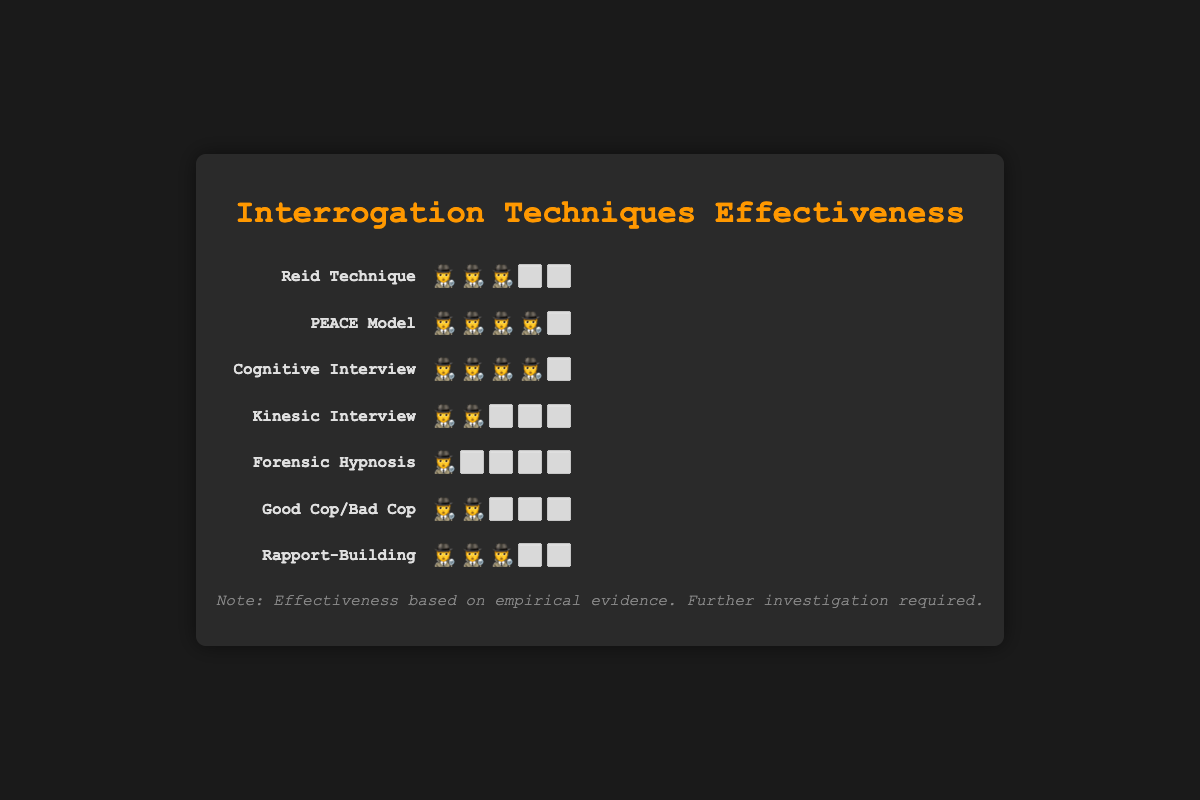Which interrogation technique has the lowest success rate based on the emoji scale? The figure shows that "Forensic Hypnosis" has the fewest emojis (🕵️⬜⬜⬜⬜), indicating it has the lowest success rate.
Answer: Forensic Hypnosis How many techniques have a success rate represented by four emojis? "PEACE Model" and "Cognitive Interview" both have four emojis (🕵️🕵️🕵️🕵️⬜). To determine the number, count these techniques.
Answer: 2 Which techniques have an equal success rate of three emojis? By observing the emoji scales, "Reid Technique" and "Rapport-Building" each have three emojis (🕵️🕵️🕵️⬜⬜).
Answer: Reid Technique, Rapport-Building What is the difference in success rate between the "PEACE Model" and "Good Cop/Bad Cop"? "PEACE Model" has four emojis (🕵️🕵️🕵️🕵️⬜) and "Good Cop/Bad Cop" has two emojis (🕵️🕵️⬜⬜⬜). The difference is 4 - 2 = 2.
Answer: 2 Which techniques share the same success rate as the "Reid Technique"? The "Reid Technique" has three emojis (🕵️🕵️🕵️⬜⬜). "Rapport-Building" also has three emojis.
Answer: Rapport-Building Rank the techniques from highest to lowest success rate based on the emoji scale. The techniques can be ranked by counting the emojis from most to least. "PEACE Model" and "Cognitive Interview" have the highest (four emojis), followed by "Reid Technique" and "Rapport-Building" (three emojis), "Kinesic Interview" and "Good Cop/Bad Cop" (two emojis), and "Forensic Hypnosis" has the lowest success rate (one emoji).
Answer: PEACE Model, Cognitive Interview, Reid Technique, Rapport-Building, Kinesic Interview, Good Cop/Bad Cop, Forensic Hypnosis How many techniques have a success rate less than three emojis? Observing the emoji scales, "Kinesic Interview" (two emojis), "Good Cop/Bad Cop" (two emojis), and "Forensic Hypnosis" (one emoji) all have fewer than three emojis. There are three such techniques in total.
Answer: 3 What is the combined success rate of the "Kinesic Interview" and "Cognitive Interview"? The "Kinesic Interview" has two emojis (🕵️🕵️⬜⬜⬜) and "Cognitive Interview" has four emojis (🕵️🕵️🕵️🕵️⬜). The combined success rate is 2 + 4 = 6 emojis.
Answer: 6 